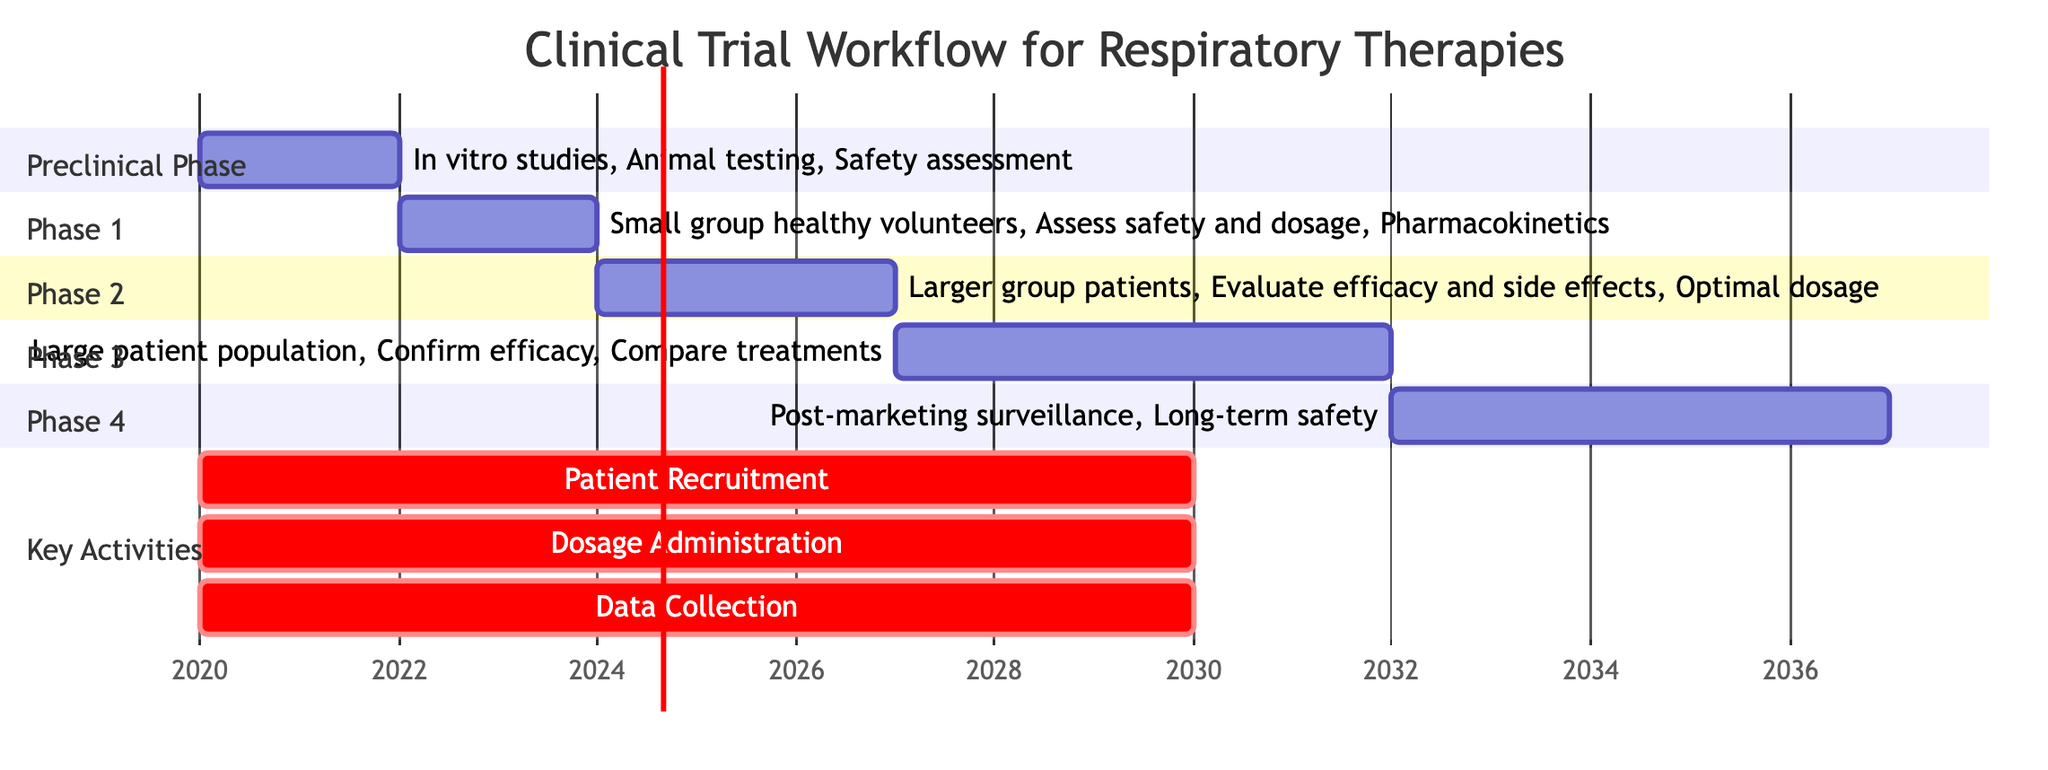What is the duration of the Phase 1 trial? The Phase 1 trial starts after the Preclinical Phase and lasts for 2 years, as indicated in the timeline of the diagram.
Answer: 2y Which key activity lasts for the entire duration of the clinical trial process? The diagram shows that Patient Recruitment is a critical activity that spans from the beginning of the Preclinical Phase to the end of the Phase 4, lasting for 10 years in total.
Answer: 10y What phase follows Phase 2? According to the diagram, Phase 2 is followed by Phase 3, which is clearly indicated in the chronological sequence of the phases.
Answer: Phase 3 What is the main focus of Phase 4? The diagram specifies that Phase 4 focuses on Post-marketing surveillance and long-term safety, representing key activities in this phase.
Answer: Long-term safety How many years does the entire clinical trial process take from the Preclinical Phase to the end of Phase 4? To find the total duration, we add the durations of all phases: 2y (Preclinical) + 2y (Phase 1) + 3y (Phase 2) + 5y (Phase 3) + 5y (Phase 4), which sums up to 17 years.
Answer: 17y Which is the longest phase of the clinical trial workflow? From the diagram, Phase 3 is indicated to last for 5 years, which is the longest duration of any individual phase in the workflow.
Answer: Phase 3 How many major trial phases are depicted in the workflow? The diagram illustrates a total of four major phases: Preclinical, Phase 1, Phase 2, and Phase 3, alongside Phase 4, making it five altogether.
Answer: 5 What are the three critical activities shown in the diagram? The diagram identifies Patient Recruitment, Dosage Administration, and Data Collection as the three critical activities occurring throughout the clinical trial process.
Answer: Patient Recruitment, Dosage Administration, and Data Collection In which year does the data collection process start? The diagram shows that the Data Collection activity starts in 2020, coinciding with the beginning of the Preclinical Phase.
Answer: 2020 